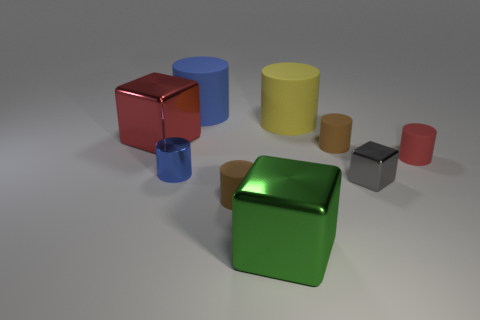Subtract all blue blocks. How many blue cylinders are left? 2 Subtract all red cylinders. How many cylinders are left? 5 Subtract all large cubes. How many cubes are left? 1 Subtract 3 cylinders. How many cylinders are left? 3 Subtract all green cylinders. Subtract all brown cubes. How many cylinders are left? 6 Subtract all cylinders. How many objects are left? 3 Add 3 brown rubber cylinders. How many brown rubber cylinders are left? 5 Add 5 yellow balls. How many yellow balls exist? 5 Subtract 0 purple spheres. How many objects are left? 9 Subtract all tiny blue things. Subtract all big blocks. How many objects are left? 6 